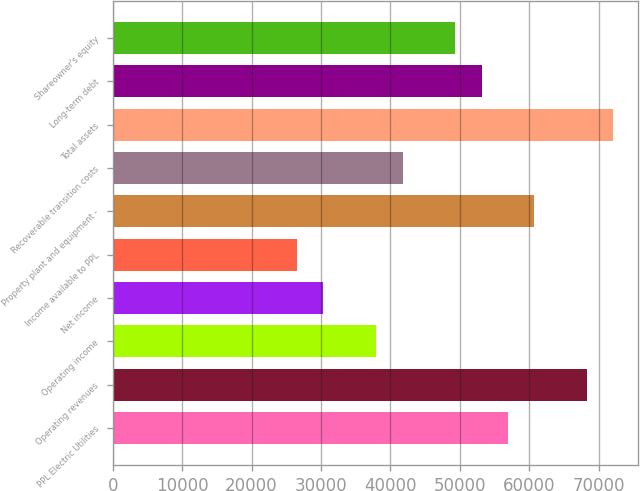Convert chart to OTSL. <chart><loc_0><loc_0><loc_500><loc_500><bar_chart><fcel>PPL Electric Utilities<fcel>Operating revenues<fcel>Operating income<fcel>Net income<fcel>Income available to PPL<fcel>Property plant and equipment -<fcel>Recoverable transition costs<fcel>Total assets<fcel>Long-term debt<fcel>Shareowner's equity<nl><fcel>56923.8<fcel>68308.2<fcel>37950<fcel>30360.5<fcel>26565.7<fcel>60718.6<fcel>41744.8<fcel>72102.9<fcel>53129.1<fcel>49334.3<nl></chart> 